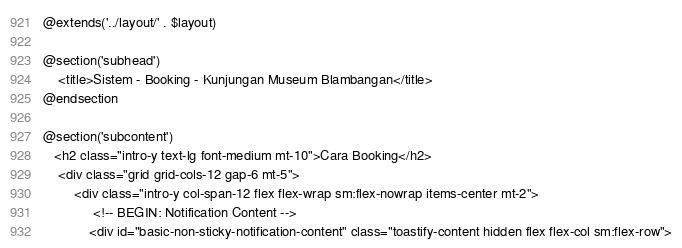<code> <loc_0><loc_0><loc_500><loc_500><_PHP_>@extends('../layout/' . $layout)

@section('subhead')
    <title>Sistem - Booking - Kunjungan Museum Blambangan</title>
@endsection

@section('subcontent')
   <h2 class="intro-y text-lg font-medium mt-10">Cara Booking</h2>
    <div class="grid grid-cols-12 gap-6 mt-5">
        <div class="intro-y col-span-12 flex flex-wrap sm:flex-nowrap items-center mt-2">
             <!-- BEGIN: Notification Content -->
            <div id="basic-non-sticky-notification-content" class="toastify-content hidden flex flex-col sm:flex-row"></code> 